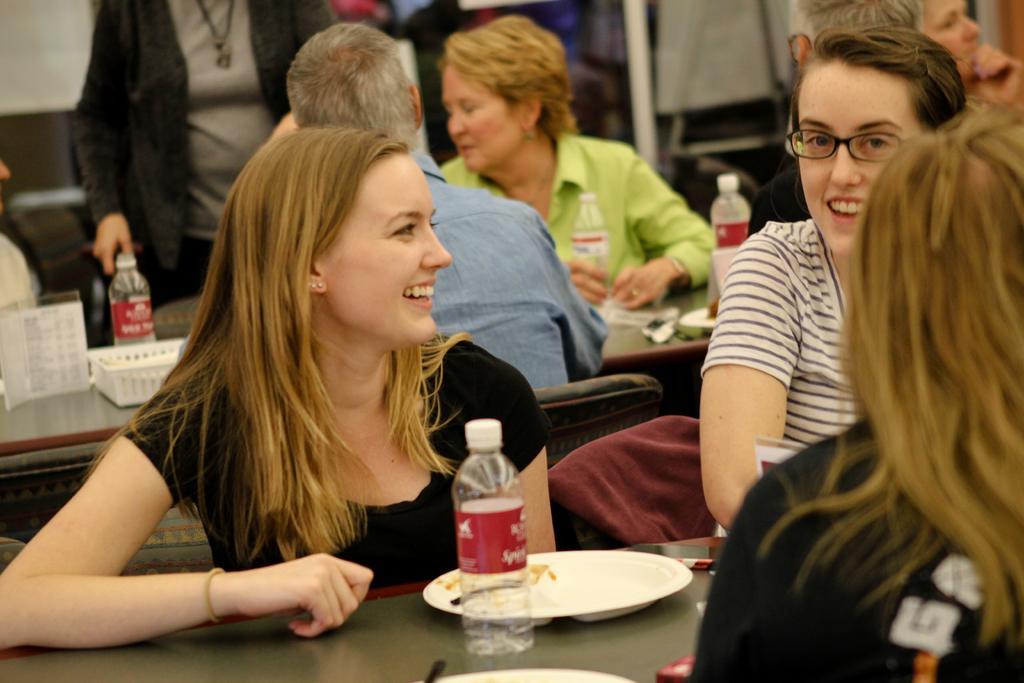Please provide a concise description of this image. Here we can see a group of people sitting on chairs with tables in front of them having plates and bottle of water on it 